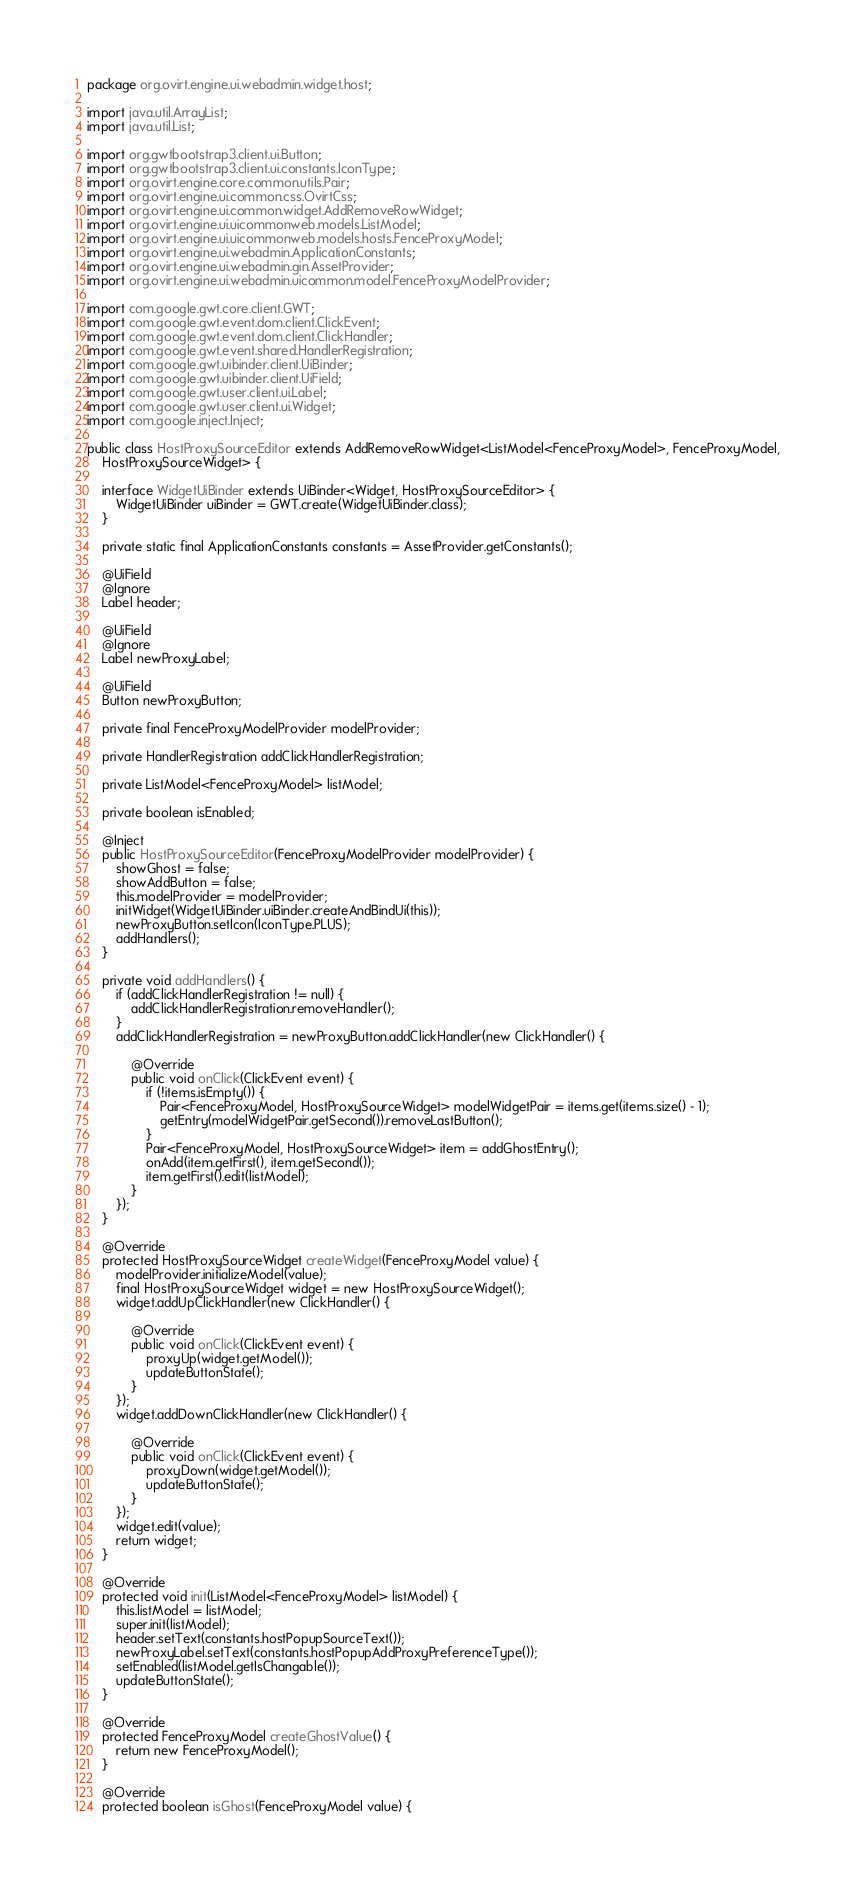<code> <loc_0><loc_0><loc_500><loc_500><_Java_>package org.ovirt.engine.ui.webadmin.widget.host;

import java.util.ArrayList;
import java.util.List;

import org.gwtbootstrap3.client.ui.Button;
import org.gwtbootstrap3.client.ui.constants.IconType;
import org.ovirt.engine.core.common.utils.Pair;
import org.ovirt.engine.ui.common.css.OvirtCss;
import org.ovirt.engine.ui.common.widget.AddRemoveRowWidget;
import org.ovirt.engine.ui.uicommonweb.models.ListModel;
import org.ovirt.engine.ui.uicommonweb.models.hosts.FenceProxyModel;
import org.ovirt.engine.ui.webadmin.ApplicationConstants;
import org.ovirt.engine.ui.webadmin.gin.AssetProvider;
import org.ovirt.engine.ui.webadmin.uicommon.model.FenceProxyModelProvider;

import com.google.gwt.core.client.GWT;
import com.google.gwt.event.dom.client.ClickEvent;
import com.google.gwt.event.dom.client.ClickHandler;
import com.google.gwt.event.shared.HandlerRegistration;
import com.google.gwt.uibinder.client.UiBinder;
import com.google.gwt.uibinder.client.UiField;
import com.google.gwt.user.client.ui.Label;
import com.google.gwt.user.client.ui.Widget;
import com.google.inject.Inject;

public class HostProxySourceEditor extends AddRemoveRowWidget<ListModel<FenceProxyModel>, FenceProxyModel,
    HostProxySourceWidget> {

    interface WidgetUiBinder extends UiBinder<Widget, HostProxySourceEditor> {
        WidgetUiBinder uiBinder = GWT.create(WidgetUiBinder.class);
    }

    private static final ApplicationConstants constants = AssetProvider.getConstants();

    @UiField
    @Ignore
    Label header;

    @UiField
    @Ignore
    Label newProxyLabel;

    @UiField
    Button newProxyButton;

    private final FenceProxyModelProvider modelProvider;

    private HandlerRegistration addClickHandlerRegistration;

    private ListModel<FenceProxyModel> listModel;

    private boolean isEnabled;

    @Inject
    public HostProxySourceEditor(FenceProxyModelProvider modelProvider) {
        showGhost = false;
        showAddButton = false;
        this.modelProvider = modelProvider;
        initWidget(WidgetUiBinder.uiBinder.createAndBindUi(this));
        newProxyButton.setIcon(IconType.PLUS);
        addHandlers();
    }

    private void addHandlers() {
        if (addClickHandlerRegistration != null) {
            addClickHandlerRegistration.removeHandler();
        }
        addClickHandlerRegistration = newProxyButton.addClickHandler(new ClickHandler() {

            @Override
            public void onClick(ClickEvent event) {
                if (!items.isEmpty()) {
                    Pair<FenceProxyModel, HostProxySourceWidget> modelWidgetPair = items.get(items.size() - 1);
                    getEntry(modelWidgetPair.getSecond()).removeLastButton();
                }
                Pair<FenceProxyModel, HostProxySourceWidget> item = addGhostEntry();
                onAdd(item.getFirst(), item.getSecond());
                item.getFirst().edit(listModel);
            }
        });
    }

    @Override
    protected HostProxySourceWidget createWidget(FenceProxyModel value) {
        modelProvider.initializeModel(value);
        final HostProxySourceWidget widget = new HostProxySourceWidget();
        widget.addUpClickHandler(new ClickHandler() {

            @Override
            public void onClick(ClickEvent event) {
                proxyUp(widget.getModel());
                updateButtonState();
            }
        });
        widget.addDownClickHandler(new ClickHandler() {

            @Override
            public void onClick(ClickEvent event) {
                proxyDown(widget.getModel());
                updateButtonState();
            }
        });
        widget.edit(value);
        return widget;
    }

    @Override
    protected void init(ListModel<FenceProxyModel> listModel) {
        this.listModel = listModel;
        super.init(listModel);
        header.setText(constants.hostPopupSourceText());
        newProxyLabel.setText(constants.hostPopupAddProxyPreferenceType());
        setEnabled(listModel.getIsChangable());
        updateButtonState();
    }

    @Override
    protected FenceProxyModel createGhostValue() {
        return new FenceProxyModel();
    }

    @Override
    protected boolean isGhost(FenceProxyModel value) {</code> 